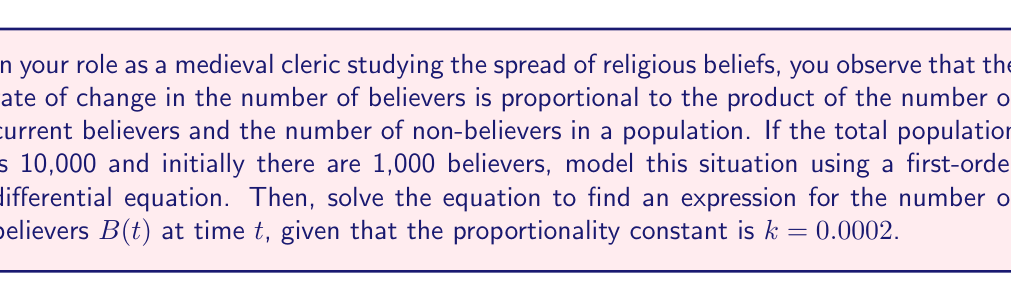Teach me how to tackle this problem. Let's approach this step-by-step:

1) Let $B(t)$ be the number of believers at time $t$. The total population is 10,000, so the number of non-believers is $10000 - B(t)$.

2) The rate of change of believers is proportional to the product of believers and non-believers:

   $$\frac{dB}{dt} = kB(t)(10000 - B(t))$$

   where $k = 0.0002$ is the proportionality constant.

3) This is a separable differential equation. Let's separate the variables:

   $$\frac{dB}{B(10000 - B)} = 0.0002 dt$$

4) Integrate both sides:

   $$\int \frac{dB}{B(10000 - B)} = \int 0.0002 dt$$

5) The left side can be integrated using partial fractions:

   $$\frac{1}{10000} \int (\frac{1}{B} + \frac{1}{10000-B}) dB = 0.0002t + C$$

6) Evaluating the integral:

   $$\frac{1}{10000} [\ln|B| - \ln|10000-B|] = 0.0002t + C$$

7) Simplify:

   $$\ln|\frac{B}{10000-B}| = 2t + C'$$

   where $C'$ is a new constant.

8) Take the exponential of both sides:

   $$\frac{B}{10000-B} = Ae^{2t}$$

   where $A = e^{C'}$ is a positive constant.

9) Solve for $B$:

   $$B = \frac{10000Ae^{2t}}{1+Ae^{2t}}$$

10) Use the initial condition: $B(0) = 1000$ to find $A$:

    $$1000 = \frac{10000A}{1+A}$$

    Solving this, we get $A = \frac{1}{9}$

11) Therefore, the final solution is:

    $$B(t) = \frac{10000(\frac{1}{9})e^{2t}}{1+(\frac{1}{9})e^{2t}} = \frac{10000e^{2t}}{9+e^{2t}}$$
Answer: $$B(t) = \frac{10000e^{2t}}{9+e^{2t}}$$ 